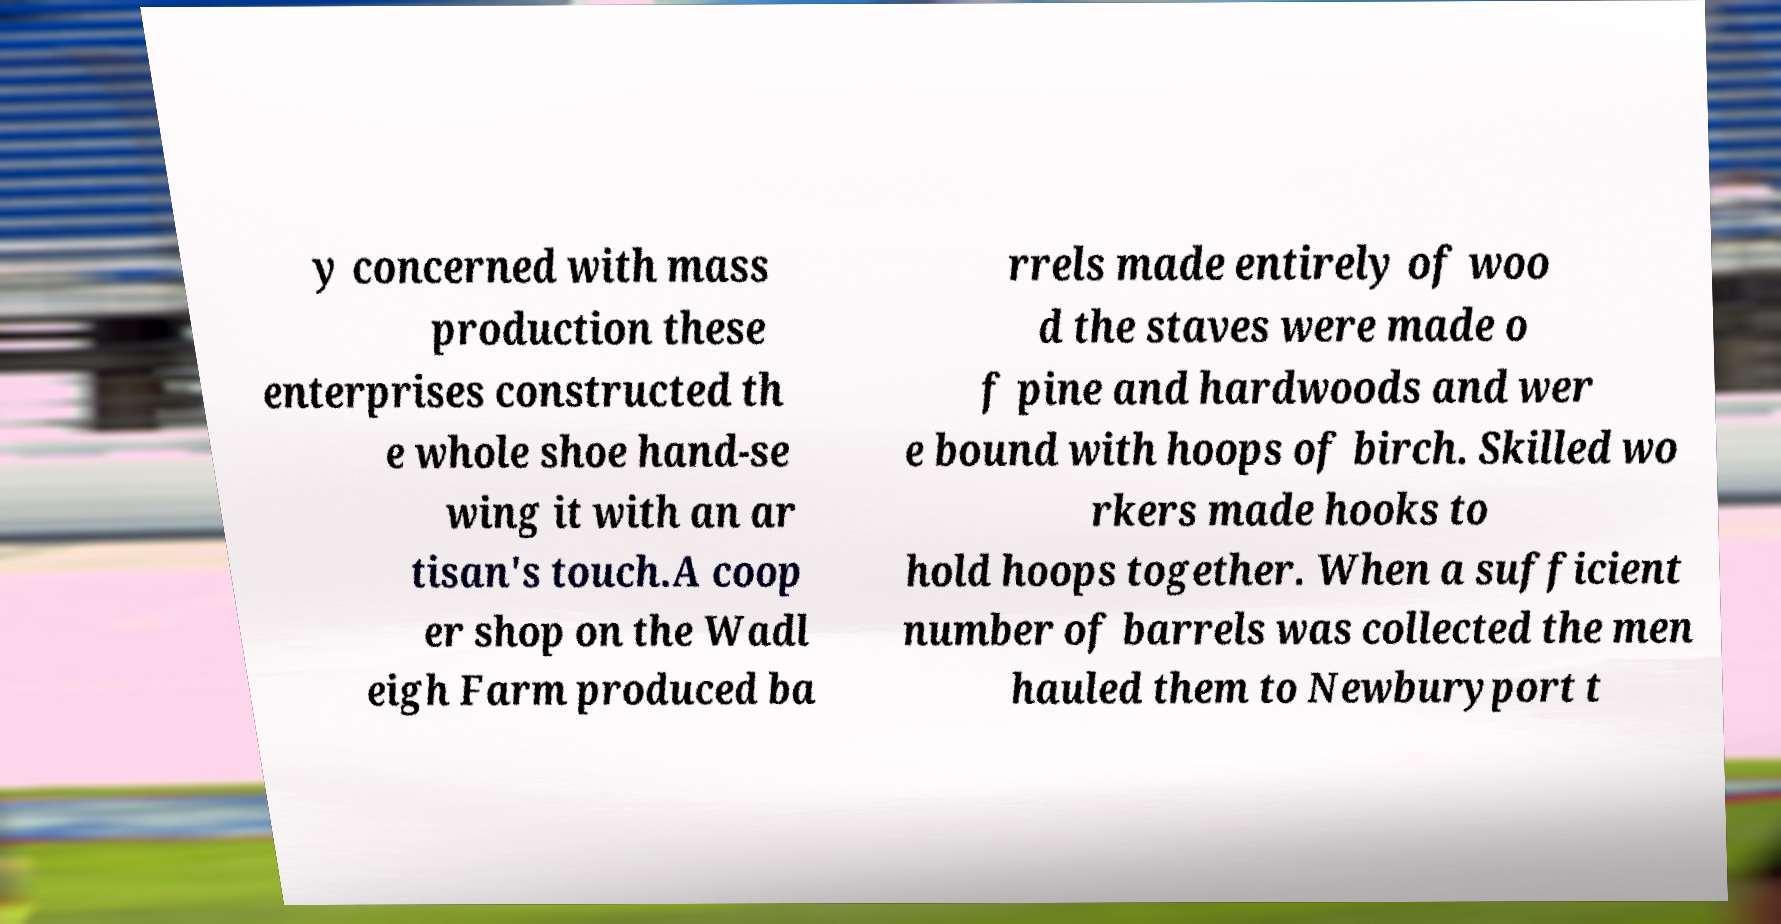Please identify and transcribe the text found in this image. y concerned with mass production these enterprises constructed th e whole shoe hand-se wing it with an ar tisan's touch.A coop er shop on the Wadl eigh Farm produced ba rrels made entirely of woo d the staves were made o f pine and hardwoods and wer e bound with hoops of birch. Skilled wo rkers made hooks to hold hoops together. When a sufficient number of barrels was collected the men hauled them to Newburyport t 